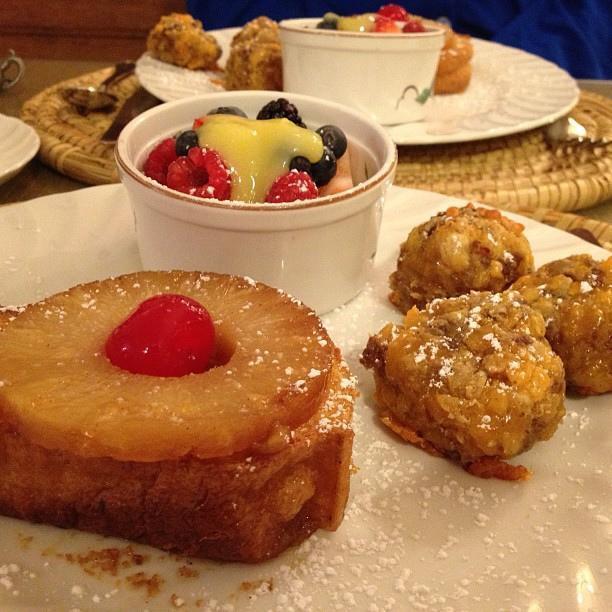How many bowls are in the picture?
Give a very brief answer. 2. How many people are watching the player?
Give a very brief answer. 0. 